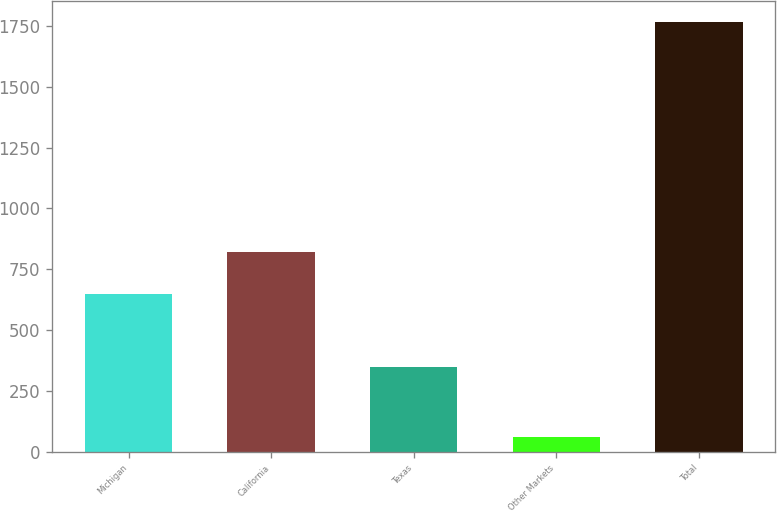<chart> <loc_0><loc_0><loc_500><loc_500><bar_chart><fcel>Michigan<fcel>California<fcel>Texas<fcel>Other Markets<fcel>Total<nl><fcel>650<fcel>820.6<fcel>346<fcel>59<fcel>1765<nl></chart> 